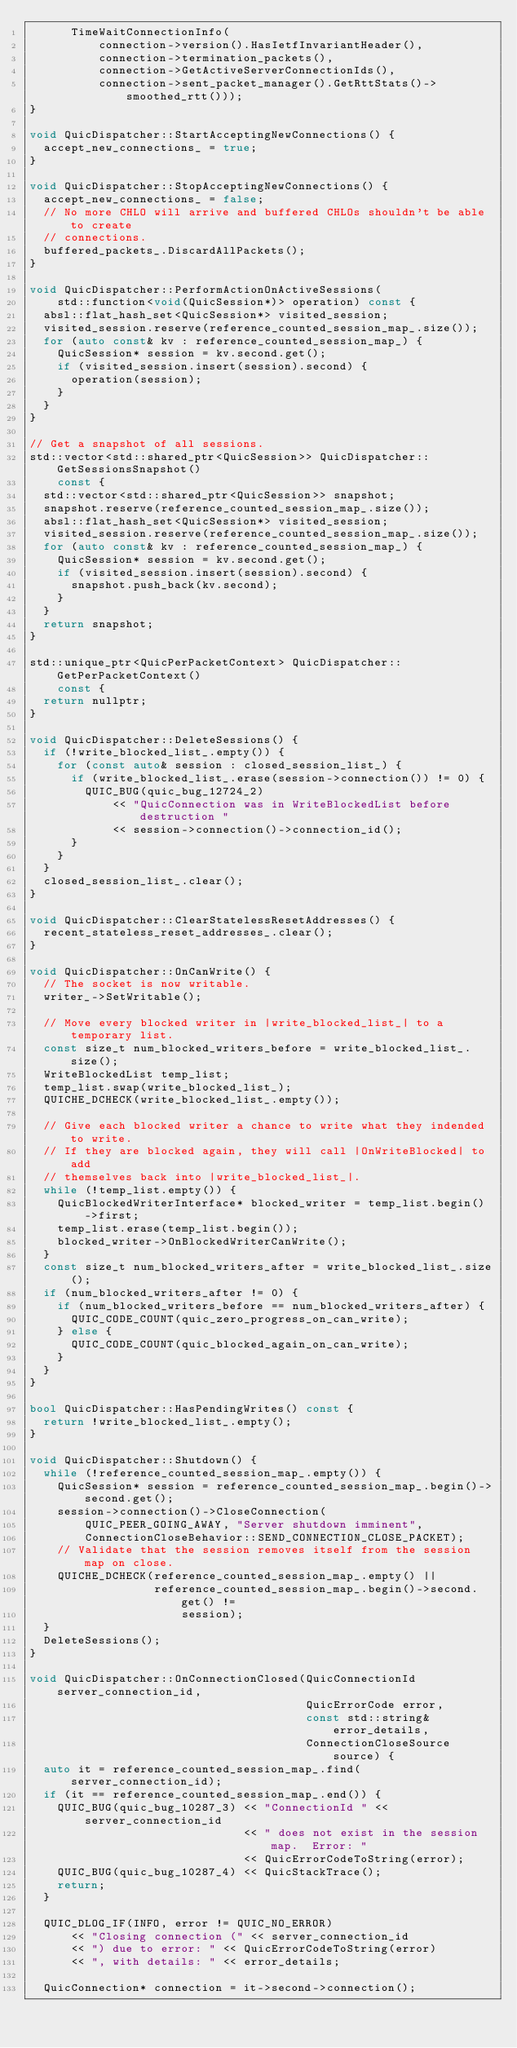<code> <loc_0><loc_0><loc_500><loc_500><_C++_>      TimeWaitConnectionInfo(
          connection->version().HasIetfInvariantHeader(),
          connection->termination_packets(),
          connection->GetActiveServerConnectionIds(),
          connection->sent_packet_manager().GetRttStats()->smoothed_rtt()));
}

void QuicDispatcher::StartAcceptingNewConnections() {
  accept_new_connections_ = true;
}

void QuicDispatcher::StopAcceptingNewConnections() {
  accept_new_connections_ = false;
  // No more CHLO will arrive and buffered CHLOs shouldn't be able to create
  // connections.
  buffered_packets_.DiscardAllPackets();
}

void QuicDispatcher::PerformActionOnActiveSessions(
    std::function<void(QuicSession*)> operation) const {
  absl::flat_hash_set<QuicSession*> visited_session;
  visited_session.reserve(reference_counted_session_map_.size());
  for (auto const& kv : reference_counted_session_map_) {
    QuicSession* session = kv.second.get();
    if (visited_session.insert(session).second) {
      operation(session);
    }
  }
}

// Get a snapshot of all sessions.
std::vector<std::shared_ptr<QuicSession>> QuicDispatcher::GetSessionsSnapshot()
    const {
  std::vector<std::shared_ptr<QuicSession>> snapshot;
  snapshot.reserve(reference_counted_session_map_.size());
  absl::flat_hash_set<QuicSession*> visited_session;
  visited_session.reserve(reference_counted_session_map_.size());
  for (auto const& kv : reference_counted_session_map_) {
    QuicSession* session = kv.second.get();
    if (visited_session.insert(session).second) {
      snapshot.push_back(kv.second);
    }
  }
  return snapshot;
}

std::unique_ptr<QuicPerPacketContext> QuicDispatcher::GetPerPacketContext()
    const {
  return nullptr;
}

void QuicDispatcher::DeleteSessions() {
  if (!write_blocked_list_.empty()) {
    for (const auto& session : closed_session_list_) {
      if (write_blocked_list_.erase(session->connection()) != 0) {
        QUIC_BUG(quic_bug_12724_2)
            << "QuicConnection was in WriteBlockedList before destruction "
            << session->connection()->connection_id();
      }
    }
  }
  closed_session_list_.clear();
}

void QuicDispatcher::ClearStatelessResetAddresses() {
  recent_stateless_reset_addresses_.clear();
}

void QuicDispatcher::OnCanWrite() {
  // The socket is now writable.
  writer_->SetWritable();

  // Move every blocked writer in |write_blocked_list_| to a temporary list.
  const size_t num_blocked_writers_before = write_blocked_list_.size();
  WriteBlockedList temp_list;
  temp_list.swap(write_blocked_list_);
  QUICHE_DCHECK(write_blocked_list_.empty());

  // Give each blocked writer a chance to write what they indended to write.
  // If they are blocked again, they will call |OnWriteBlocked| to add
  // themselves back into |write_blocked_list_|.
  while (!temp_list.empty()) {
    QuicBlockedWriterInterface* blocked_writer = temp_list.begin()->first;
    temp_list.erase(temp_list.begin());
    blocked_writer->OnBlockedWriterCanWrite();
  }
  const size_t num_blocked_writers_after = write_blocked_list_.size();
  if (num_blocked_writers_after != 0) {
    if (num_blocked_writers_before == num_blocked_writers_after) {
      QUIC_CODE_COUNT(quic_zero_progress_on_can_write);
    } else {
      QUIC_CODE_COUNT(quic_blocked_again_on_can_write);
    }
  }
}

bool QuicDispatcher::HasPendingWrites() const {
  return !write_blocked_list_.empty();
}

void QuicDispatcher::Shutdown() {
  while (!reference_counted_session_map_.empty()) {
    QuicSession* session = reference_counted_session_map_.begin()->second.get();
    session->connection()->CloseConnection(
        QUIC_PEER_GOING_AWAY, "Server shutdown imminent",
        ConnectionCloseBehavior::SEND_CONNECTION_CLOSE_PACKET);
    // Validate that the session removes itself from the session map on close.
    QUICHE_DCHECK(reference_counted_session_map_.empty() ||
                  reference_counted_session_map_.begin()->second.get() !=
                      session);
  }
  DeleteSessions();
}

void QuicDispatcher::OnConnectionClosed(QuicConnectionId server_connection_id,
                                        QuicErrorCode error,
                                        const std::string& error_details,
                                        ConnectionCloseSource source) {
  auto it = reference_counted_session_map_.find(server_connection_id);
  if (it == reference_counted_session_map_.end()) {
    QUIC_BUG(quic_bug_10287_3) << "ConnectionId " << server_connection_id
                               << " does not exist in the session map.  Error: "
                               << QuicErrorCodeToString(error);
    QUIC_BUG(quic_bug_10287_4) << QuicStackTrace();
    return;
  }

  QUIC_DLOG_IF(INFO, error != QUIC_NO_ERROR)
      << "Closing connection (" << server_connection_id
      << ") due to error: " << QuicErrorCodeToString(error)
      << ", with details: " << error_details;

  QuicConnection* connection = it->second->connection();</code> 